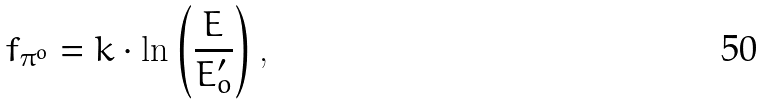Convert formula to latex. <formula><loc_0><loc_0><loc_500><loc_500>f _ { \pi ^ { o } } = k \cdot \ln \left ( { \frac { E } { E _ { o } ^ { \prime } } } \right ) ,</formula> 